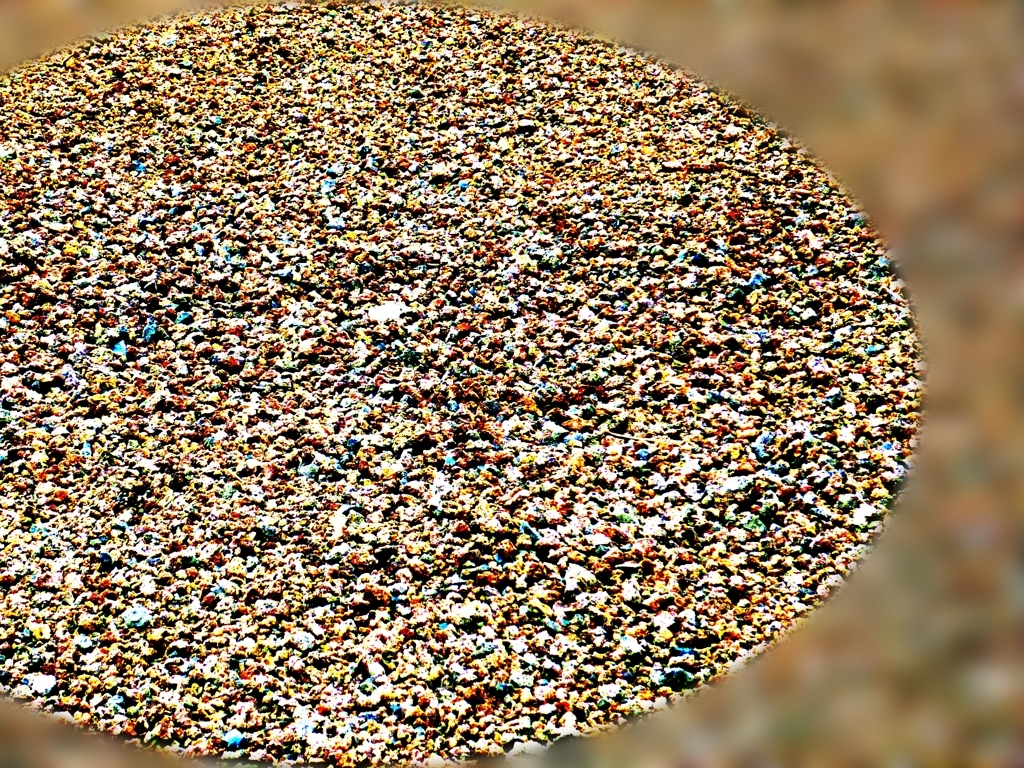Can you tell me more about the colors used in this image? Certainly! The image boasts a diverse palette, with rich blues, greens, yellows, and reds that stand out against each other, contributing to the image's overall vibrancy and visual interest. 